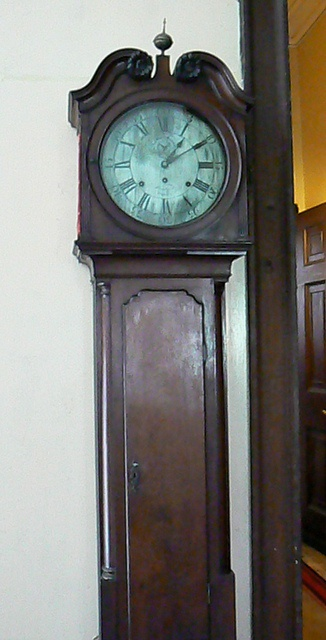Describe the objects in this image and their specific colors. I can see a clock in lightgray, teal, and lightblue tones in this image. 